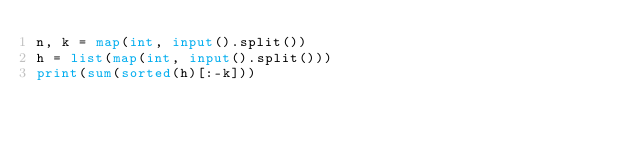<code> <loc_0><loc_0><loc_500><loc_500><_Python_>n, k = map(int, input().split())
h = list(map(int, input().split()))
print(sum(sorted(h)[:-k]))</code> 